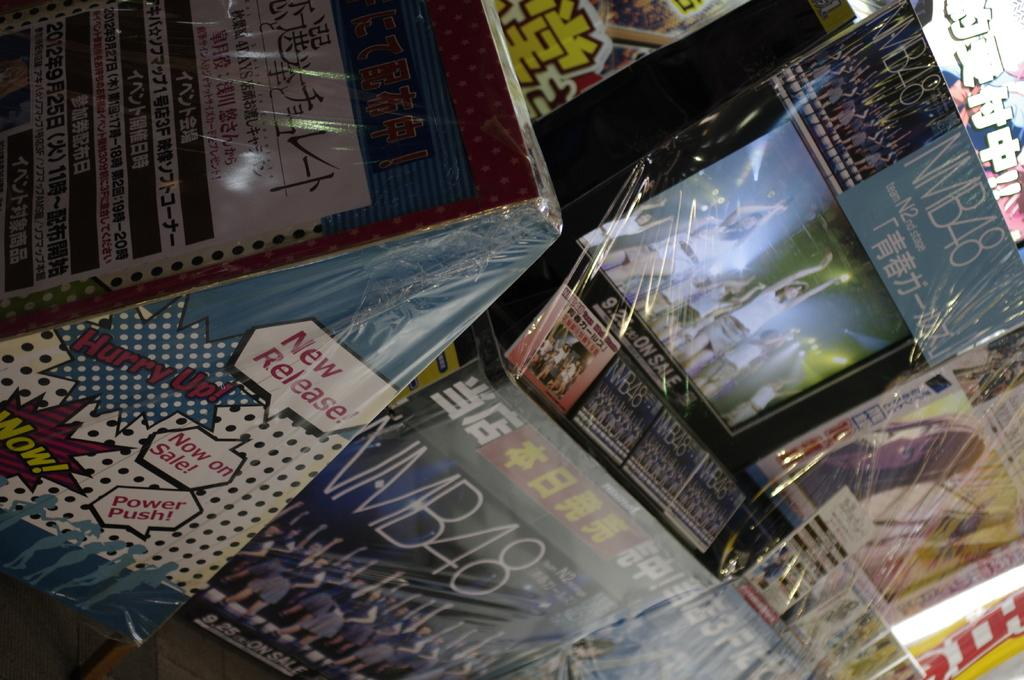Provide a one-sentence caption for the provided image. A comic book display reads "Hurry up! Now on Sale!. 